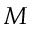<formula> <loc_0><loc_0><loc_500><loc_500>M</formula> 